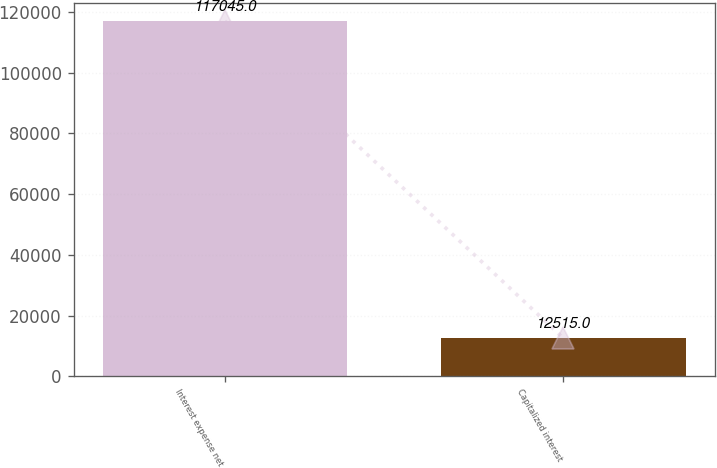Convert chart to OTSL. <chart><loc_0><loc_0><loc_500><loc_500><bar_chart><fcel>Interest expense net<fcel>Capitalized interest<nl><fcel>117045<fcel>12515<nl></chart> 